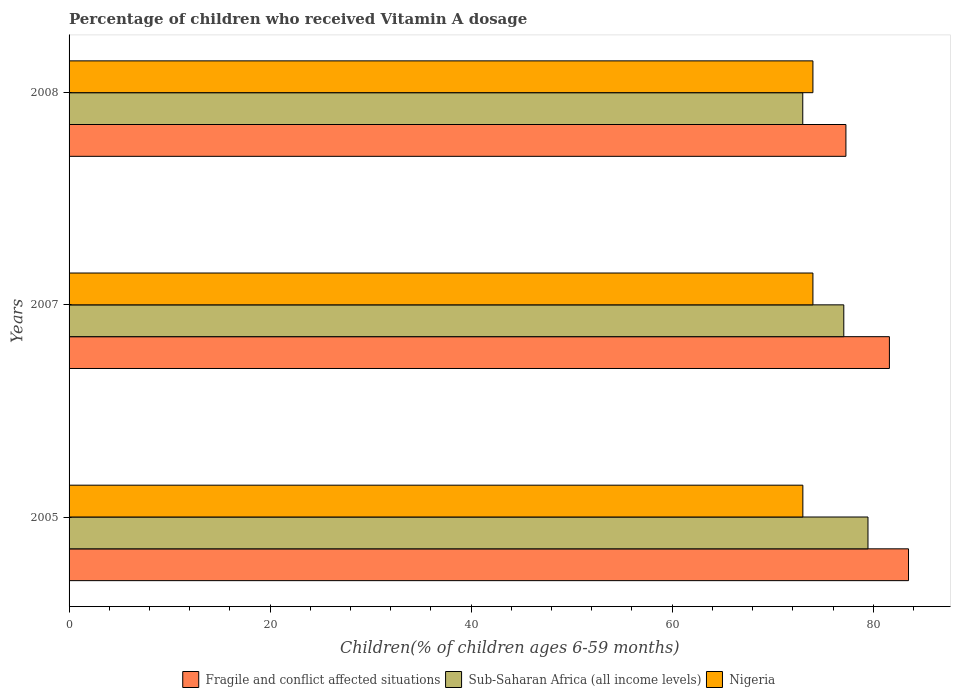How many groups of bars are there?
Offer a terse response. 3. How many bars are there on the 3rd tick from the top?
Give a very brief answer. 3. What is the label of the 3rd group of bars from the top?
Keep it short and to the point. 2005. What is the percentage of children who received Vitamin A dosage in Sub-Saharan Africa (all income levels) in 2005?
Your answer should be compact. 79.48. Across all years, what is the maximum percentage of children who received Vitamin A dosage in Sub-Saharan Africa (all income levels)?
Give a very brief answer. 79.48. Across all years, what is the minimum percentage of children who received Vitamin A dosage in Sub-Saharan Africa (all income levels)?
Your answer should be very brief. 72.99. In which year was the percentage of children who received Vitamin A dosage in Sub-Saharan Africa (all income levels) maximum?
Keep it short and to the point. 2005. In which year was the percentage of children who received Vitamin A dosage in Nigeria minimum?
Make the answer very short. 2005. What is the total percentage of children who received Vitamin A dosage in Sub-Saharan Africa (all income levels) in the graph?
Your answer should be very brief. 229.54. What is the difference between the percentage of children who received Vitamin A dosage in Fragile and conflict affected situations in 2008 and the percentage of children who received Vitamin A dosage in Nigeria in 2007?
Give a very brief answer. 3.28. What is the average percentage of children who received Vitamin A dosage in Sub-Saharan Africa (all income levels) per year?
Provide a short and direct response. 76.51. In the year 2007, what is the difference between the percentage of children who received Vitamin A dosage in Fragile and conflict affected situations and percentage of children who received Vitamin A dosage in Nigeria?
Keep it short and to the point. 7.61. In how many years, is the percentage of children who received Vitamin A dosage in Sub-Saharan Africa (all income levels) greater than 48 %?
Offer a very short reply. 3. What is the ratio of the percentage of children who received Vitamin A dosage in Fragile and conflict affected situations in 2007 to that in 2008?
Keep it short and to the point. 1.06. Is the percentage of children who received Vitamin A dosage in Fragile and conflict affected situations in 2005 less than that in 2007?
Provide a succinct answer. No. What is the difference between the highest and the lowest percentage of children who received Vitamin A dosage in Sub-Saharan Africa (all income levels)?
Offer a very short reply. 6.49. In how many years, is the percentage of children who received Vitamin A dosage in Sub-Saharan Africa (all income levels) greater than the average percentage of children who received Vitamin A dosage in Sub-Saharan Africa (all income levels) taken over all years?
Your response must be concise. 2. Is the sum of the percentage of children who received Vitamin A dosage in Sub-Saharan Africa (all income levels) in 2005 and 2008 greater than the maximum percentage of children who received Vitamin A dosage in Nigeria across all years?
Make the answer very short. Yes. What does the 3rd bar from the top in 2007 represents?
Offer a terse response. Fragile and conflict affected situations. What does the 1st bar from the bottom in 2008 represents?
Give a very brief answer. Fragile and conflict affected situations. Is it the case that in every year, the sum of the percentage of children who received Vitamin A dosage in Fragile and conflict affected situations and percentage of children who received Vitamin A dosage in Sub-Saharan Africa (all income levels) is greater than the percentage of children who received Vitamin A dosage in Nigeria?
Ensure brevity in your answer.  Yes. Are all the bars in the graph horizontal?
Your answer should be very brief. Yes. How many years are there in the graph?
Provide a short and direct response. 3. Where does the legend appear in the graph?
Keep it short and to the point. Bottom center. How are the legend labels stacked?
Your answer should be compact. Horizontal. What is the title of the graph?
Offer a very short reply. Percentage of children who received Vitamin A dosage. What is the label or title of the X-axis?
Make the answer very short. Children(% of children ages 6-59 months). What is the label or title of the Y-axis?
Your answer should be compact. Years. What is the Children(% of children ages 6-59 months) of Fragile and conflict affected situations in 2005?
Offer a very short reply. 83.51. What is the Children(% of children ages 6-59 months) in Sub-Saharan Africa (all income levels) in 2005?
Make the answer very short. 79.48. What is the Children(% of children ages 6-59 months) in Fragile and conflict affected situations in 2007?
Your answer should be compact. 81.61. What is the Children(% of children ages 6-59 months) of Sub-Saharan Africa (all income levels) in 2007?
Provide a succinct answer. 77.07. What is the Children(% of children ages 6-59 months) of Fragile and conflict affected situations in 2008?
Give a very brief answer. 77.28. What is the Children(% of children ages 6-59 months) in Sub-Saharan Africa (all income levels) in 2008?
Provide a succinct answer. 72.99. What is the Children(% of children ages 6-59 months) of Nigeria in 2008?
Make the answer very short. 74. Across all years, what is the maximum Children(% of children ages 6-59 months) of Fragile and conflict affected situations?
Make the answer very short. 83.51. Across all years, what is the maximum Children(% of children ages 6-59 months) of Sub-Saharan Africa (all income levels)?
Make the answer very short. 79.48. Across all years, what is the maximum Children(% of children ages 6-59 months) of Nigeria?
Make the answer very short. 74. Across all years, what is the minimum Children(% of children ages 6-59 months) of Fragile and conflict affected situations?
Give a very brief answer. 77.28. Across all years, what is the minimum Children(% of children ages 6-59 months) in Sub-Saharan Africa (all income levels)?
Offer a very short reply. 72.99. What is the total Children(% of children ages 6-59 months) in Fragile and conflict affected situations in the graph?
Your answer should be very brief. 242.4. What is the total Children(% of children ages 6-59 months) in Sub-Saharan Africa (all income levels) in the graph?
Provide a succinct answer. 229.54. What is the total Children(% of children ages 6-59 months) of Nigeria in the graph?
Offer a terse response. 221. What is the difference between the Children(% of children ages 6-59 months) of Fragile and conflict affected situations in 2005 and that in 2007?
Keep it short and to the point. 1.9. What is the difference between the Children(% of children ages 6-59 months) of Sub-Saharan Africa (all income levels) in 2005 and that in 2007?
Offer a very short reply. 2.41. What is the difference between the Children(% of children ages 6-59 months) of Nigeria in 2005 and that in 2007?
Offer a very short reply. -1. What is the difference between the Children(% of children ages 6-59 months) in Fragile and conflict affected situations in 2005 and that in 2008?
Your response must be concise. 6.23. What is the difference between the Children(% of children ages 6-59 months) in Sub-Saharan Africa (all income levels) in 2005 and that in 2008?
Offer a very short reply. 6.49. What is the difference between the Children(% of children ages 6-59 months) of Fragile and conflict affected situations in 2007 and that in 2008?
Your response must be concise. 4.33. What is the difference between the Children(% of children ages 6-59 months) in Sub-Saharan Africa (all income levels) in 2007 and that in 2008?
Offer a very short reply. 4.08. What is the difference between the Children(% of children ages 6-59 months) in Nigeria in 2007 and that in 2008?
Provide a succinct answer. 0. What is the difference between the Children(% of children ages 6-59 months) of Fragile and conflict affected situations in 2005 and the Children(% of children ages 6-59 months) of Sub-Saharan Africa (all income levels) in 2007?
Offer a very short reply. 6.44. What is the difference between the Children(% of children ages 6-59 months) in Fragile and conflict affected situations in 2005 and the Children(% of children ages 6-59 months) in Nigeria in 2007?
Your answer should be compact. 9.51. What is the difference between the Children(% of children ages 6-59 months) of Sub-Saharan Africa (all income levels) in 2005 and the Children(% of children ages 6-59 months) of Nigeria in 2007?
Make the answer very short. 5.48. What is the difference between the Children(% of children ages 6-59 months) in Fragile and conflict affected situations in 2005 and the Children(% of children ages 6-59 months) in Sub-Saharan Africa (all income levels) in 2008?
Offer a very short reply. 10.52. What is the difference between the Children(% of children ages 6-59 months) in Fragile and conflict affected situations in 2005 and the Children(% of children ages 6-59 months) in Nigeria in 2008?
Offer a very short reply. 9.51. What is the difference between the Children(% of children ages 6-59 months) of Sub-Saharan Africa (all income levels) in 2005 and the Children(% of children ages 6-59 months) of Nigeria in 2008?
Offer a terse response. 5.48. What is the difference between the Children(% of children ages 6-59 months) of Fragile and conflict affected situations in 2007 and the Children(% of children ages 6-59 months) of Sub-Saharan Africa (all income levels) in 2008?
Give a very brief answer. 8.62. What is the difference between the Children(% of children ages 6-59 months) of Fragile and conflict affected situations in 2007 and the Children(% of children ages 6-59 months) of Nigeria in 2008?
Provide a succinct answer. 7.61. What is the difference between the Children(% of children ages 6-59 months) of Sub-Saharan Africa (all income levels) in 2007 and the Children(% of children ages 6-59 months) of Nigeria in 2008?
Provide a short and direct response. 3.07. What is the average Children(% of children ages 6-59 months) of Fragile and conflict affected situations per year?
Keep it short and to the point. 80.8. What is the average Children(% of children ages 6-59 months) of Sub-Saharan Africa (all income levels) per year?
Ensure brevity in your answer.  76.51. What is the average Children(% of children ages 6-59 months) of Nigeria per year?
Your response must be concise. 73.67. In the year 2005, what is the difference between the Children(% of children ages 6-59 months) in Fragile and conflict affected situations and Children(% of children ages 6-59 months) in Sub-Saharan Africa (all income levels)?
Provide a succinct answer. 4.03. In the year 2005, what is the difference between the Children(% of children ages 6-59 months) in Fragile and conflict affected situations and Children(% of children ages 6-59 months) in Nigeria?
Provide a succinct answer. 10.51. In the year 2005, what is the difference between the Children(% of children ages 6-59 months) of Sub-Saharan Africa (all income levels) and Children(% of children ages 6-59 months) of Nigeria?
Provide a short and direct response. 6.48. In the year 2007, what is the difference between the Children(% of children ages 6-59 months) of Fragile and conflict affected situations and Children(% of children ages 6-59 months) of Sub-Saharan Africa (all income levels)?
Your response must be concise. 4.54. In the year 2007, what is the difference between the Children(% of children ages 6-59 months) of Fragile and conflict affected situations and Children(% of children ages 6-59 months) of Nigeria?
Make the answer very short. 7.61. In the year 2007, what is the difference between the Children(% of children ages 6-59 months) in Sub-Saharan Africa (all income levels) and Children(% of children ages 6-59 months) in Nigeria?
Offer a very short reply. 3.07. In the year 2008, what is the difference between the Children(% of children ages 6-59 months) in Fragile and conflict affected situations and Children(% of children ages 6-59 months) in Sub-Saharan Africa (all income levels)?
Your response must be concise. 4.29. In the year 2008, what is the difference between the Children(% of children ages 6-59 months) of Fragile and conflict affected situations and Children(% of children ages 6-59 months) of Nigeria?
Your response must be concise. 3.28. In the year 2008, what is the difference between the Children(% of children ages 6-59 months) in Sub-Saharan Africa (all income levels) and Children(% of children ages 6-59 months) in Nigeria?
Provide a short and direct response. -1.01. What is the ratio of the Children(% of children ages 6-59 months) in Fragile and conflict affected situations in 2005 to that in 2007?
Offer a very short reply. 1.02. What is the ratio of the Children(% of children ages 6-59 months) in Sub-Saharan Africa (all income levels) in 2005 to that in 2007?
Provide a succinct answer. 1.03. What is the ratio of the Children(% of children ages 6-59 months) of Nigeria in 2005 to that in 2007?
Offer a terse response. 0.99. What is the ratio of the Children(% of children ages 6-59 months) in Fragile and conflict affected situations in 2005 to that in 2008?
Give a very brief answer. 1.08. What is the ratio of the Children(% of children ages 6-59 months) in Sub-Saharan Africa (all income levels) in 2005 to that in 2008?
Offer a very short reply. 1.09. What is the ratio of the Children(% of children ages 6-59 months) in Nigeria in 2005 to that in 2008?
Provide a short and direct response. 0.99. What is the ratio of the Children(% of children ages 6-59 months) of Fragile and conflict affected situations in 2007 to that in 2008?
Offer a very short reply. 1.06. What is the ratio of the Children(% of children ages 6-59 months) in Sub-Saharan Africa (all income levels) in 2007 to that in 2008?
Provide a succinct answer. 1.06. What is the ratio of the Children(% of children ages 6-59 months) of Nigeria in 2007 to that in 2008?
Give a very brief answer. 1. What is the difference between the highest and the second highest Children(% of children ages 6-59 months) in Fragile and conflict affected situations?
Give a very brief answer. 1.9. What is the difference between the highest and the second highest Children(% of children ages 6-59 months) in Sub-Saharan Africa (all income levels)?
Your answer should be compact. 2.41. What is the difference between the highest and the lowest Children(% of children ages 6-59 months) in Fragile and conflict affected situations?
Provide a succinct answer. 6.23. What is the difference between the highest and the lowest Children(% of children ages 6-59 months) in Sub-Saharan Africa (all income levels)?
Make the answer very short. 6.49. What is the difference between the highest and the lowest Children(% of children ages 6-59 months) of Nigeria?
Provide a short and direct response. 1. 